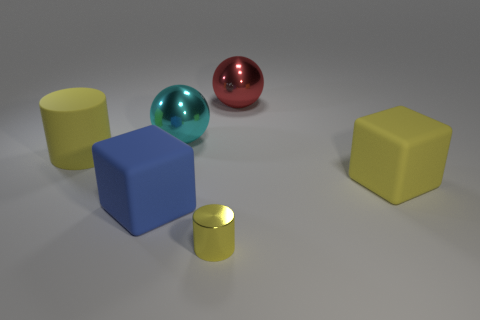There is a yellow shiny thing left of the big red sphere; is it the same shape as the big blue thing?
Ensure brevity in your answer.  No. The tiny metal thing is what color?
Keep it short and to the point. Yellow. The other metallic object that is the same shape as the cyan object is what color?
Keep it short and to the point. Red. What number of large yellow matte things have the same shape as the large red metal thing?
Provide a succinct answer. 0. How many objects are either yellow cylinders or metal balls that are on the left side of the small yellow metallic object?
Your response must be concise. 3. Does the tiny thing have the same color as the big rubber cube right of the tiny metallic cylinder?
Offer a very short reply. Yes. There is a yellow object that is both on the right side of the large cyan thing and to the left of the red metallic ball; how big is it?
Offer a terse response. Small. There is a tiny yellow shiny cylinder; are there any rubber things on the right side of it?
Offer a terse response. Yes. There is a rubber cylinder on the left side of the blue matte cube; are there any rubber cylinders that are behind it?
Provide a succinct answer. No. Are there an equal number of blocks that are to the right of the large cyan object and metallic cylinders behind the small thing?
Ensure brevity in your answer.  No. 